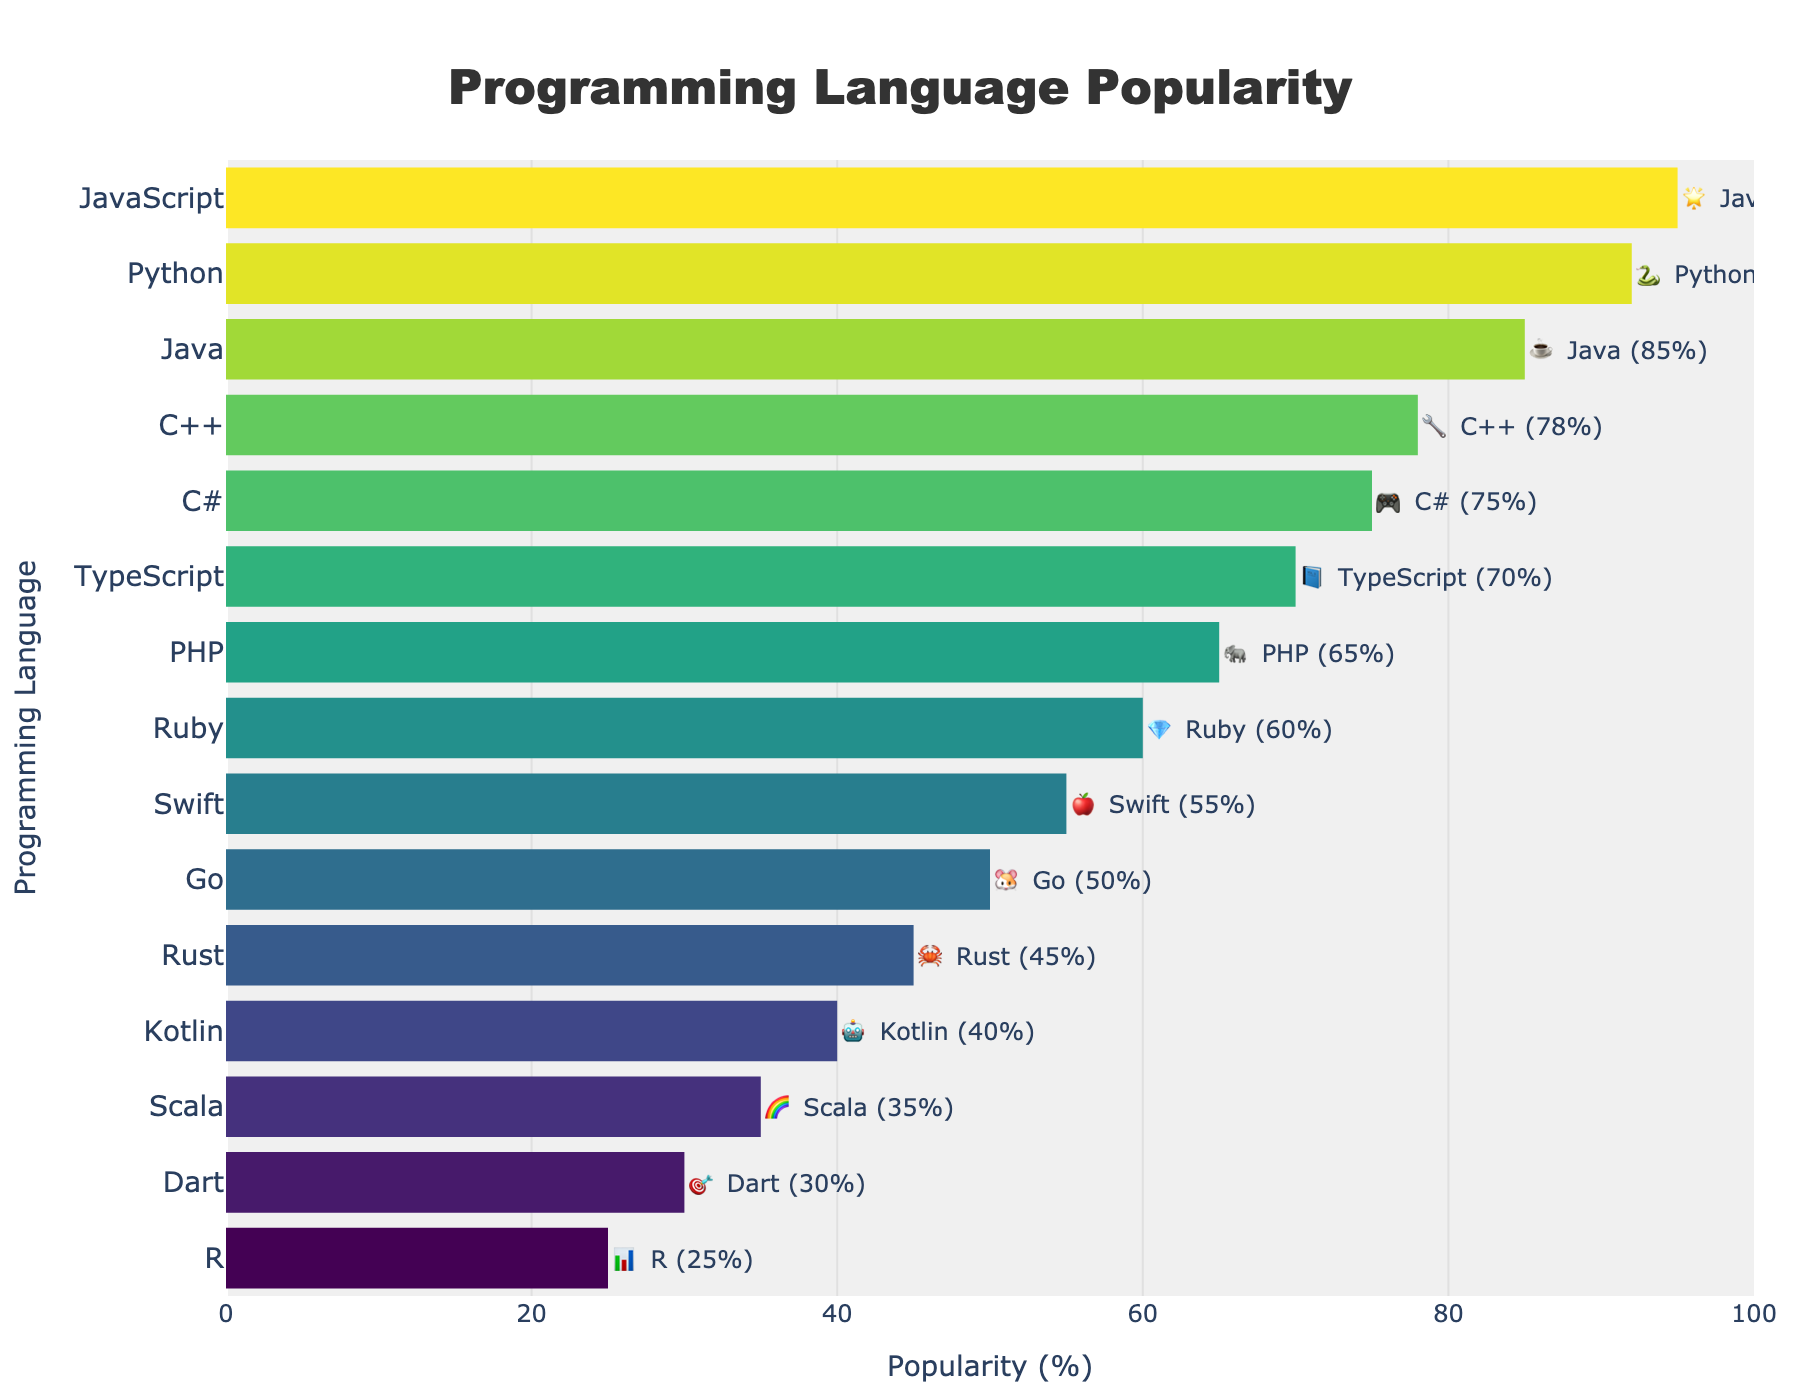What's the title of the chart? The title is the text at the top of the chart that summarizes the content. In this chart, it says "Programming Language Popularity".
Answer: Programming Language Popularity What does the y-axis represent? The y-axis lists the programming languages in the chart. Each bar corresponds to a specific language, such as JavaScript or Python.
Answer: Programming Languages Which programming language is represented by the 🐘 emoji? To answer this, look for the emoji 🐘 in the chart, then note the language name next to it.
Answer: PHP What is the popularity percentage of Python (🐍)? Look for the 🐍 emoji in the chart, then find its corresponding bar. The number at the end of the bar represents its popularity percentage.
Answer: 92 Which programming language has a higher popularity: C++ (🔧) or Rust (🦀)? Locate the bars for C++ (🔧) and Rust (🦀). Compare the numbers next to each bar. C++ is 78% and Rust is 45%; hence C++ is higher.
Answer: C++ What is the sum of the popularity percentages of the top three languages? Identify the top three languages: JavaScript (95), Python (92), and Java (85). Add their percentages together, i.e., 95 + 92 + 85 = 272.
Answer: 272 How many programming languages have a popularity percentage greater than 60%? Count the bars that extend past the 60% mark. From the data: JavaScript, Python, Java, C++, C#, TypeScript, and PHP meet this criterion.
Answer: 7 What is the median popularity percentage among all the listed languages? To find the median, list all percentages in order: 25, 30, 35, 40, 45, 50, 55, 60, 65, 70, 75, 78, 85, 92, 95. There are 15 values, so the median is the 8th value.
Answer: 55 Which programming language has the lowest popularity? Locate the shortest bar on the chart. The shortest bar represents the language with the lowest percentage, which is R at 25%.
Answer: R How much more popular is Java (☕) compared to Scala (🌈)? Find the popularity percentages of Java (85) and Scala (35). Subtract Scala's percentage from Java's percentage: 85 - 35 = 50.
Answer: 50 